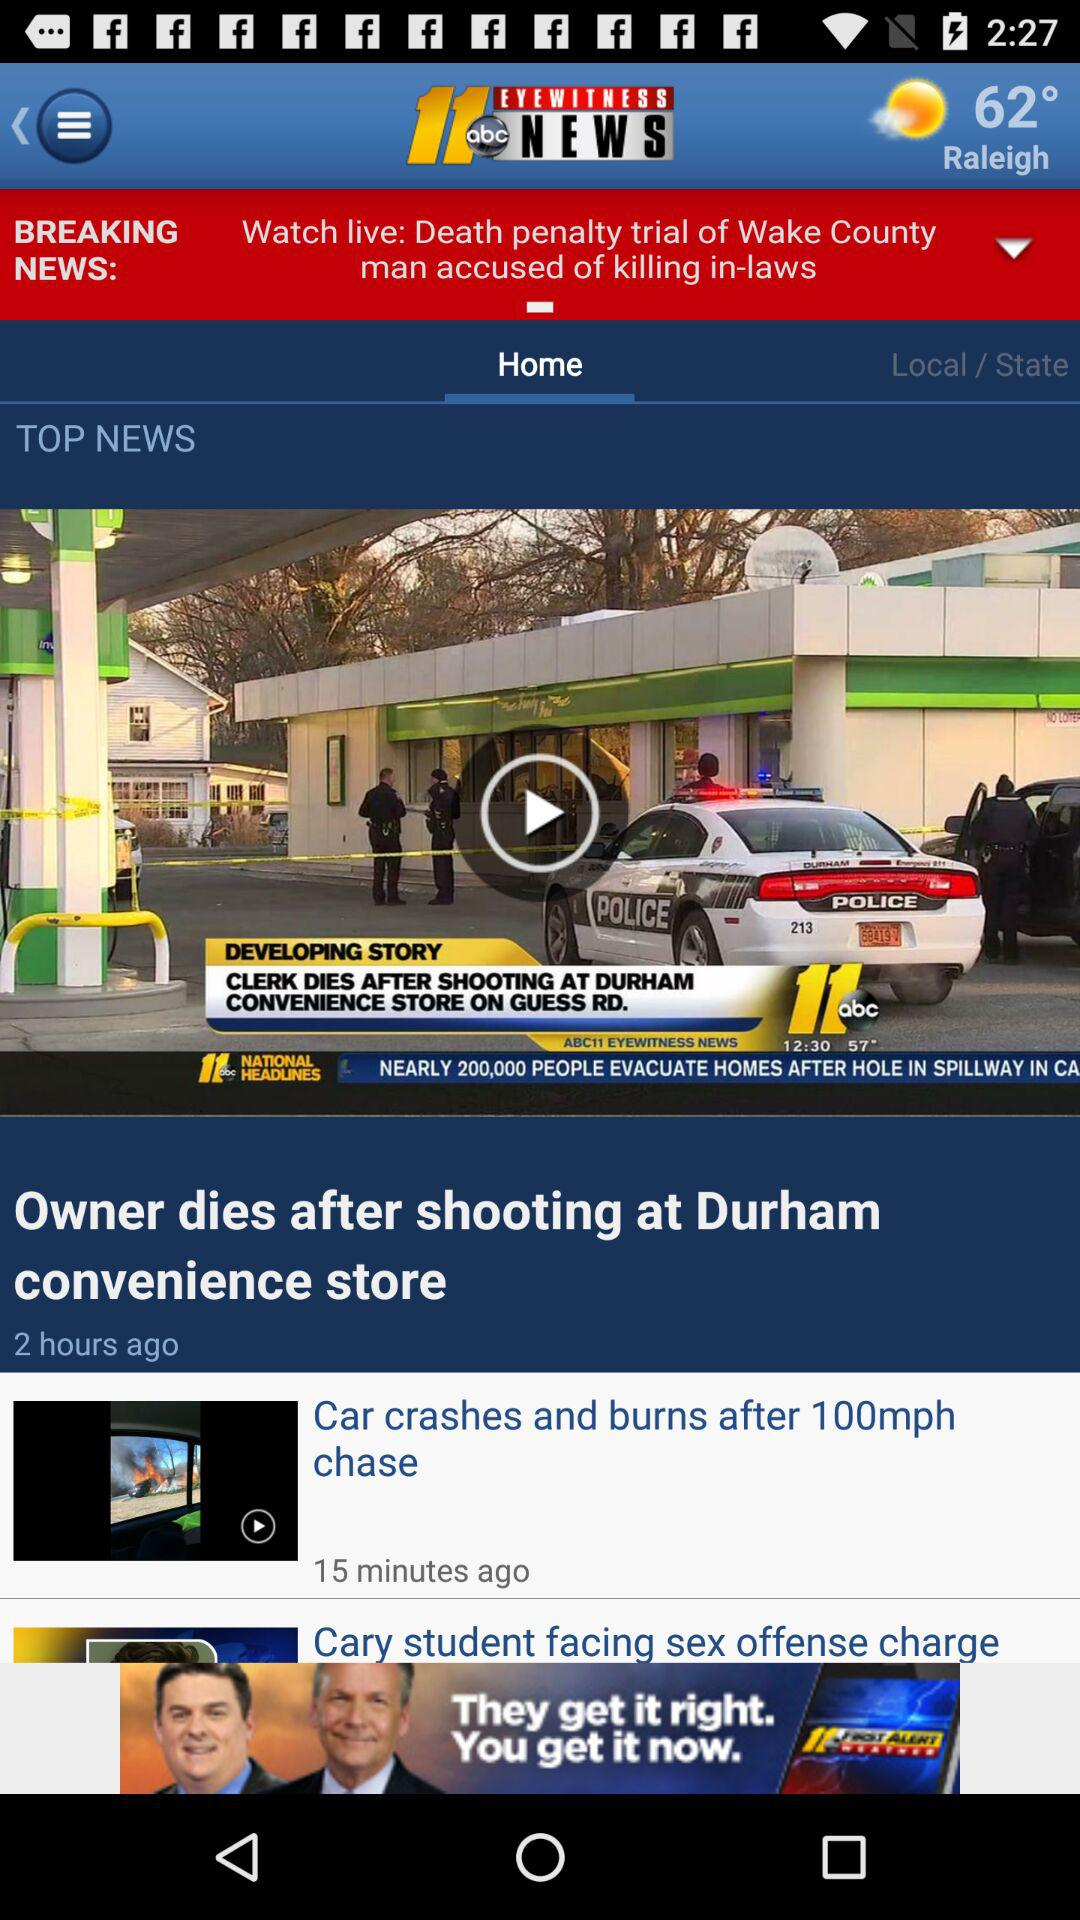What is the temperature shown on the screen? The shown temperature is 62 degrees. 